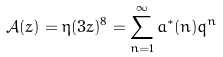Convert formula to latex. <formula><loc_0><loc_0><loc_500><loc_500>\mathcal { A } ( z ) = \eta ( 3 z ) ^ { 8 } = \sum _ { n = 1 } ^ { \infty } a ^ { * } ( n ) q ^ { n }</formula> 